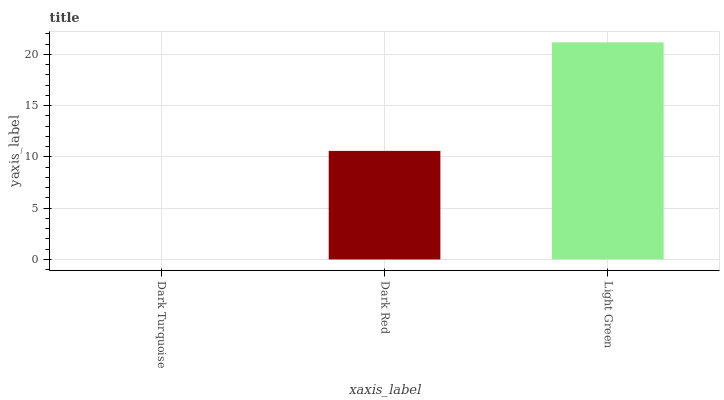Is Dark Red the minimum?
Answer yes or no. No. Is Dark Red the maximum?
Answer yes or no. No. Is Dark Red greater than Dark Turquoise?
Answer yes or no. Yes. Is Dark Turquoise less than Dark Red?
Answer yes or no. Yes. Is Dark Turquoise greater than Dark Red?
Answer yes or no. No. Is Dark Red less than Dark Turquoise?
Answer yes or no. No. Is Dark Red the high median?
Answer yes or no. Yes. Is Dark Red the low median?
Answer yes or no. Yes. Is Light Green the high median?
Answer yes or no. No. Is Dark Turquoise the low median?
Answer yes or no. No. 